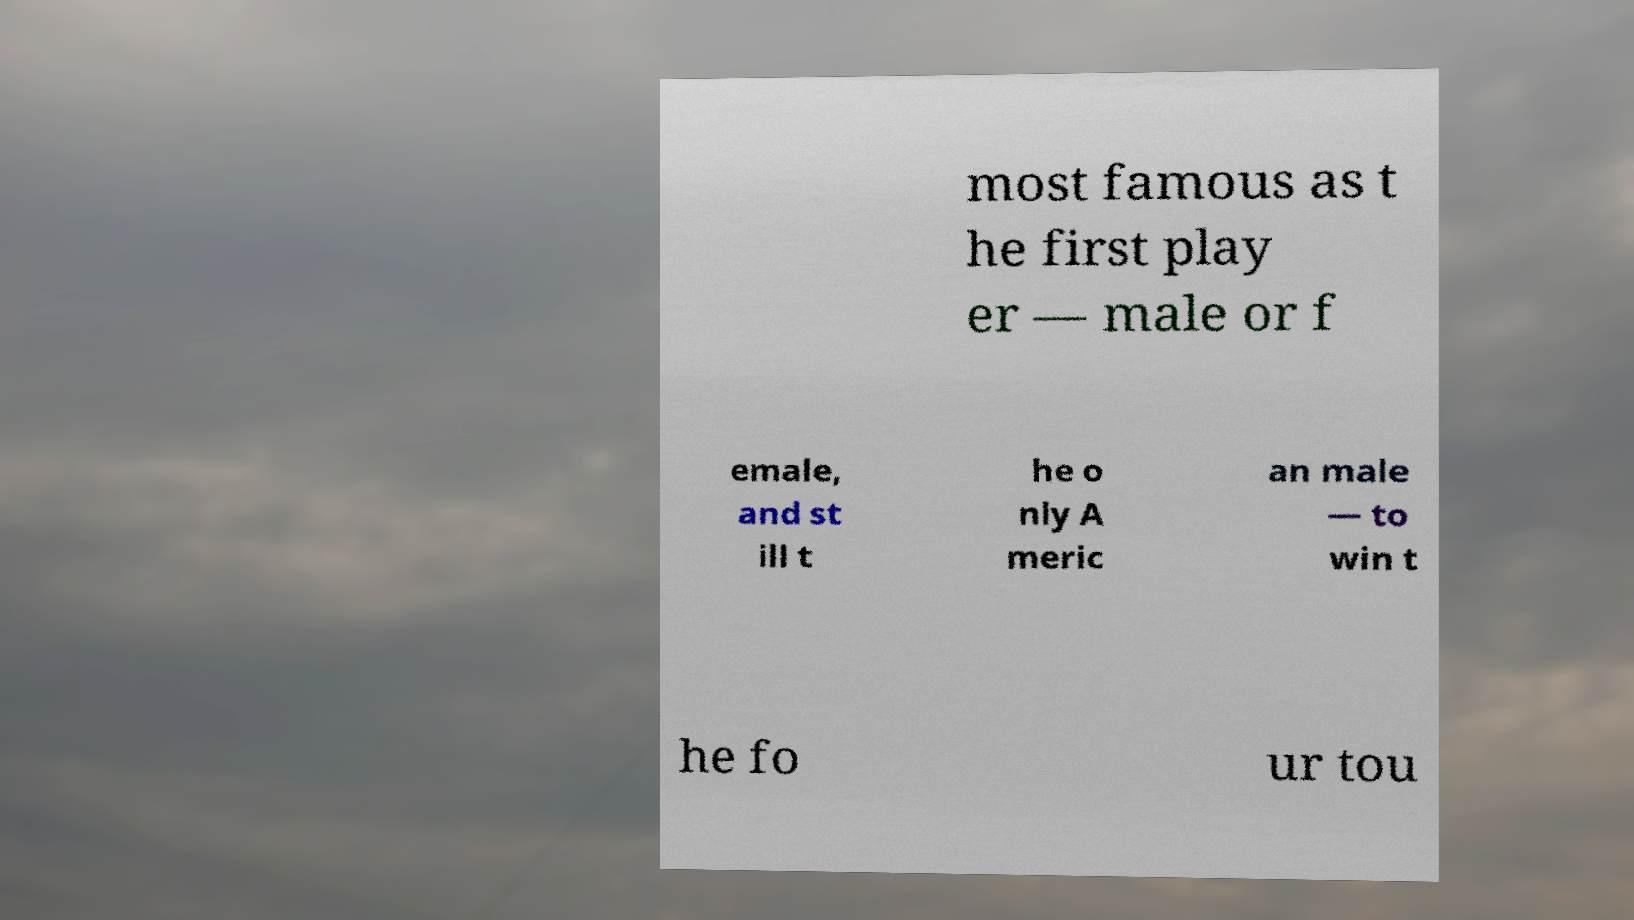Can you accurately transcribe the text from the provided image for me? most famous as t he first play er — male or f emale, and st ill t he o nly A meric an male — to win t he fo ur tou 